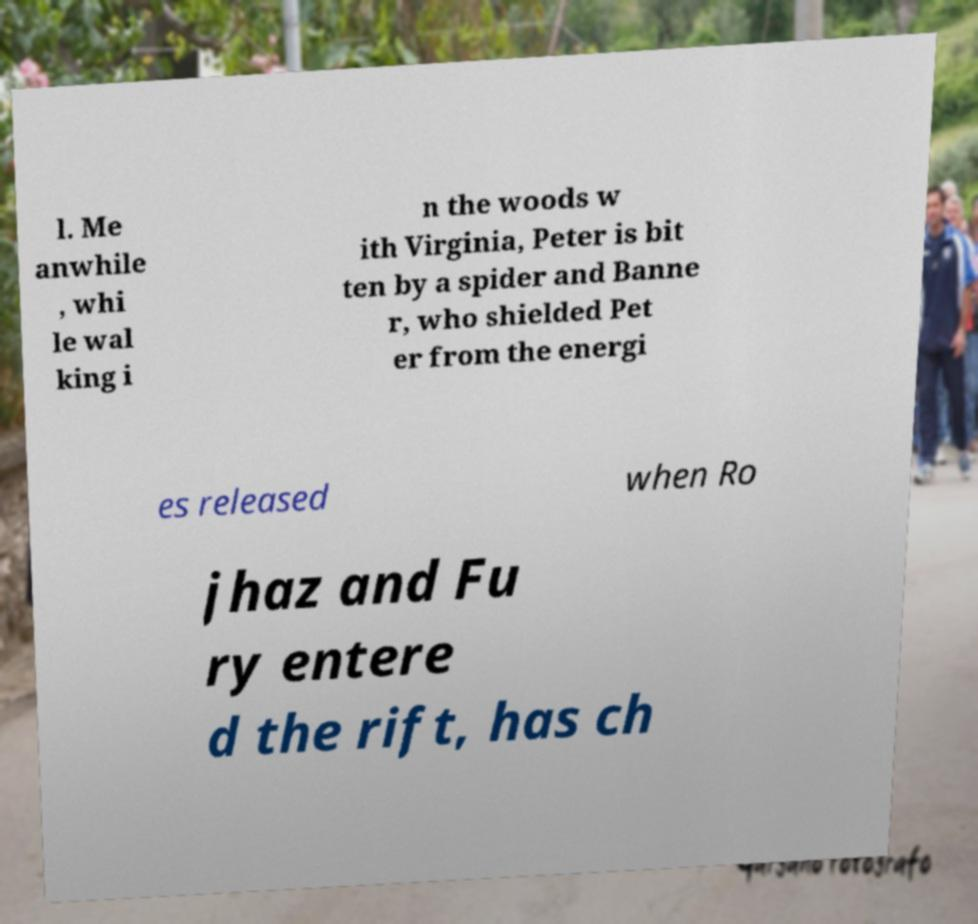There's text embedded in this image that I need extracted. Can you transcribe it verbatim? l. Me anwhile , whi le wal king i n the woods w ith Virginia, Peter is bit ten by a spider and Banne r, who shielded Pet er from the energi es released when Ro jhaz and Fu ry entere d the rift, has ch 